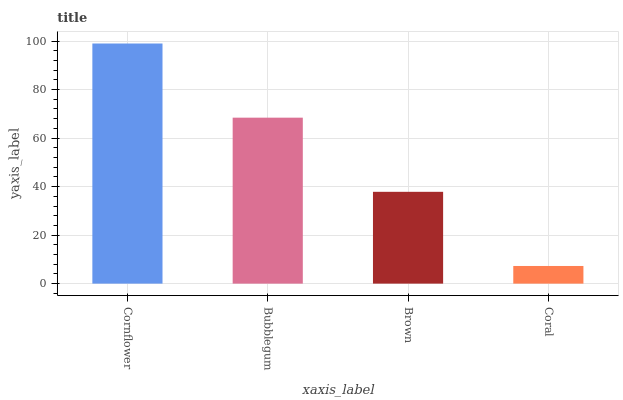Is Coral the minimum?
Answer yes or no. Yes. Is Cornflower the maximum?
Answer yes or no. Yes. Is Bubblegum the minimum?
Answer yes or no. No. Is Bubblegum the maximum?
Answer yes or no. No. Is Cornflower greater than Bubblegum?
Answer yes or no. Yes. Is Bubblegum less than Cornflower?
Answer yes or no. Yes. Is Bubblegum greater than Cornflower?
Answer yes or no. No. Is Cornflower less than Bubblegum?
Answer yes or no. No. Is Bubblegum the high median?
Answer yes or no. Yes. Is Brown the low median?
Answer yes or no. Yes. Is Coral the high median?
Answer yes or no. No. Is Coral the low median?
Answer yes or no. No. 